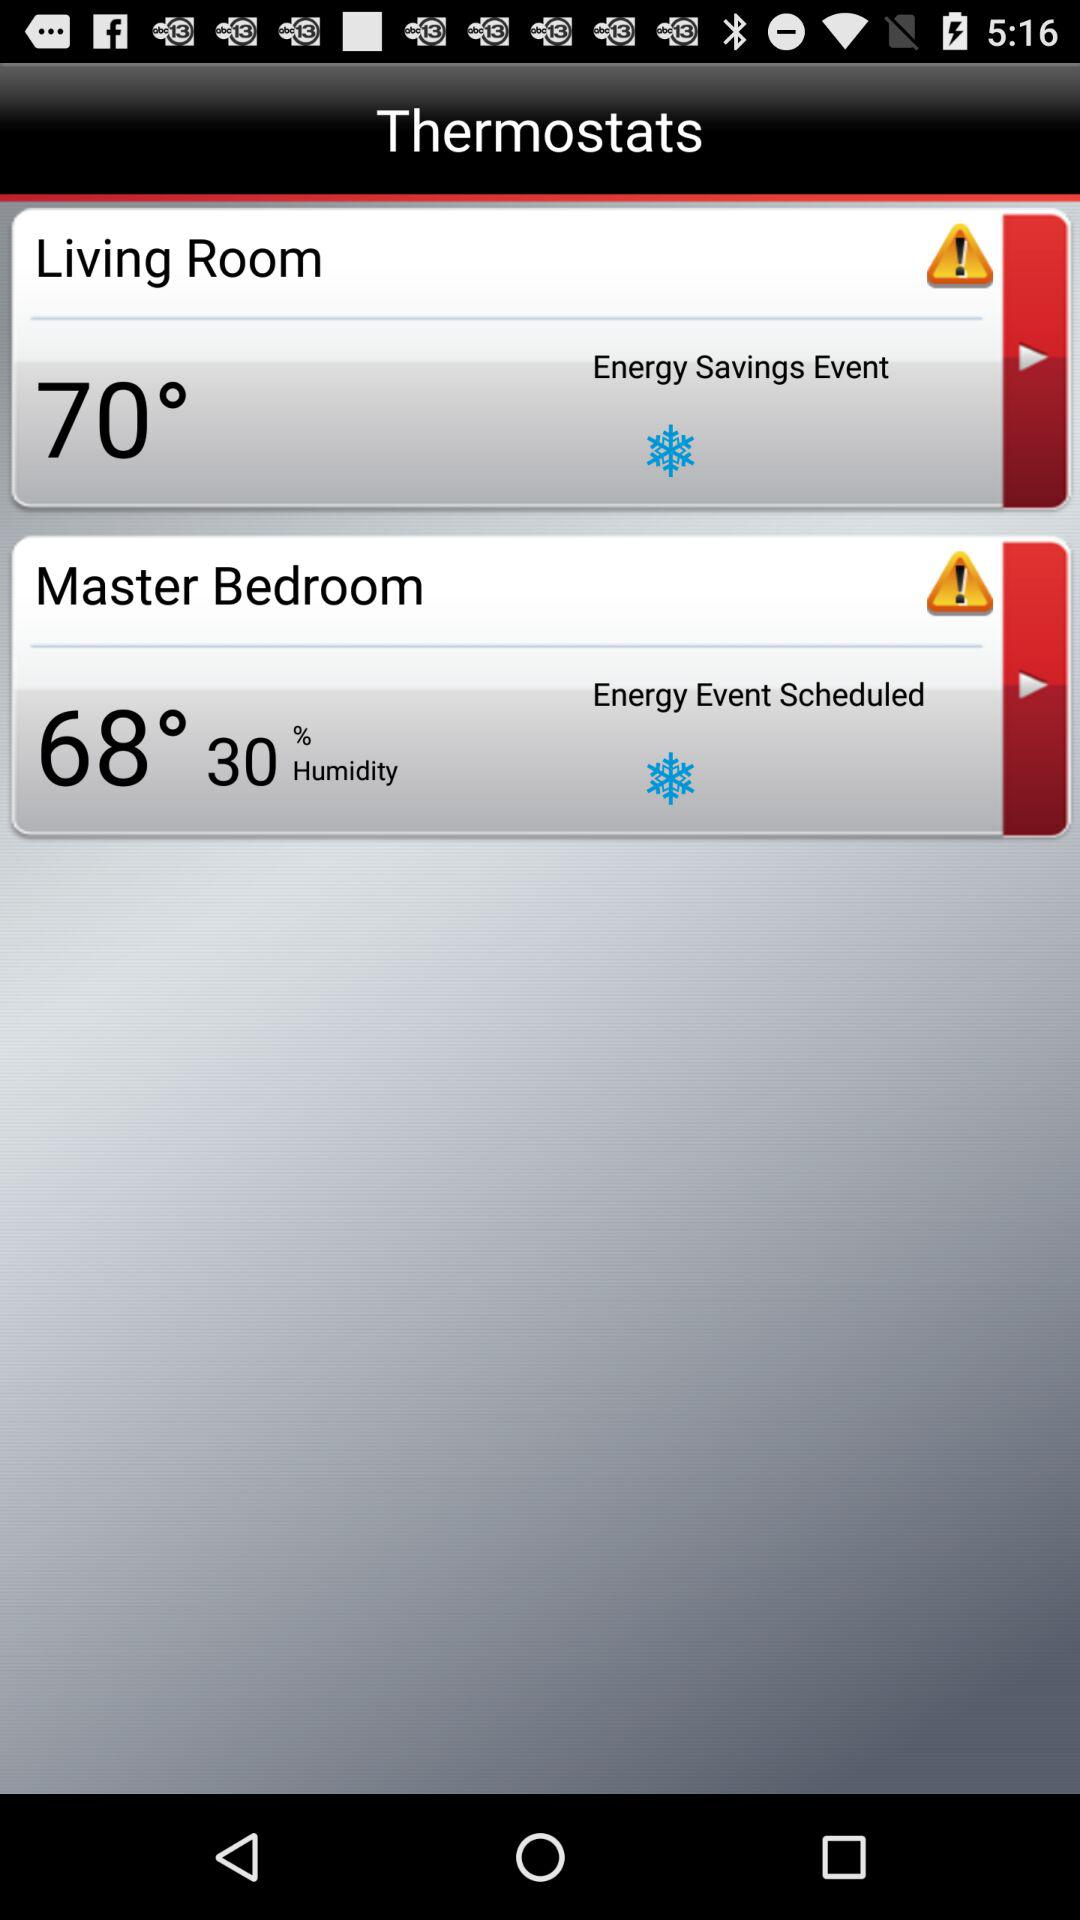How much higher is the temperature in the Living Room than in the Master Bedroom?
Answer the question using a single word or phrase. 2 